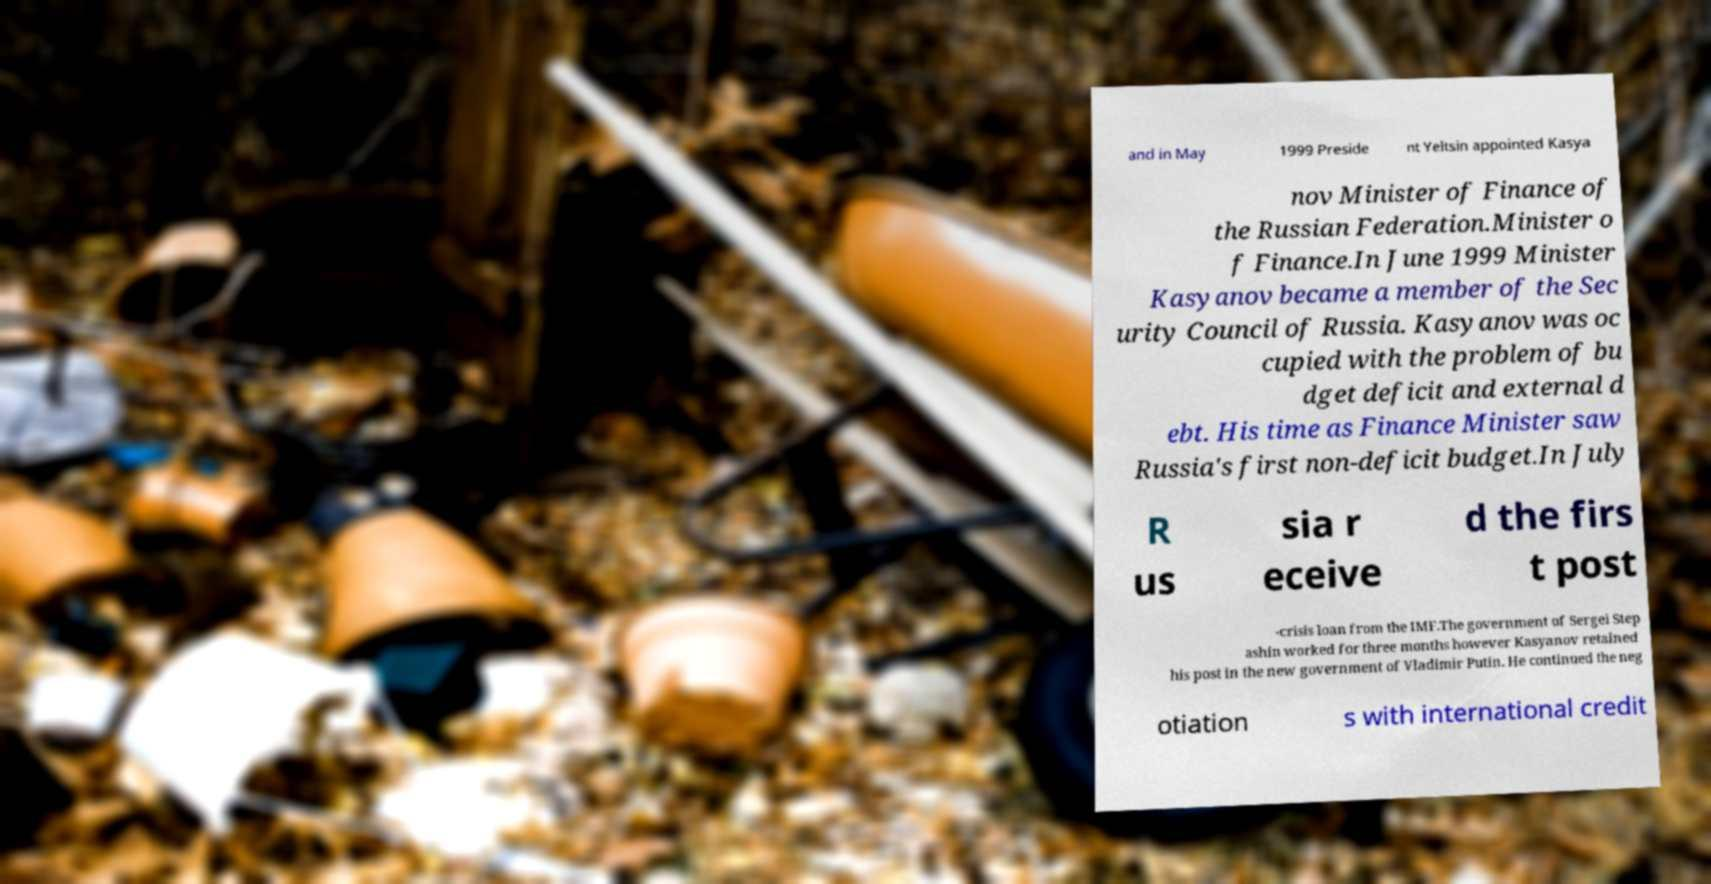I need the written content from this picture converted into text. Can you do that? and in May 1999 Preside nt Yeltsin appointed Kasya nov Minister of Finance of the Russian Federation.Minister o f Finance.In June 1999 Minister Kasyanov became a member of the Sec urity Council of Russia. Kasyanov was oc cupied with the problem of bu dget deficit and external d ebt. His time as Finance Minister saw Russia's first non-deficit budget.In July R us sia r eceive d the firs t post -crisis loan from the IMF.The government of Sergei Step ashin worked for three months however Kasyanov retained his post in the new government of Vladimir Putin. He continued the neg otiation s with international credit 